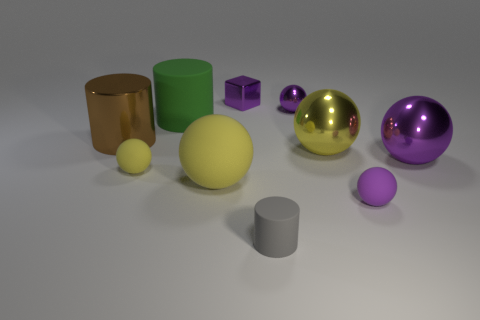Subtract all brown blocks. How many purple spheres are left? 3 Subtract all small shiny spheres. How many spheres are left? 5 Subtract all cyan spheres. Subtract all green cylinders. How many spheres are left? 6 Subtract all blocks. How many objects are left? 9 Add 8 small metal objects. How many small metal objects are left? 10 Add 4 small things. How many small things exist? 9 Subtract 0 gray cubes. How many objects are left? 10 Subtract all small purple metal cubes. Subtract all small metallic blocks. How many objects are left? 8 